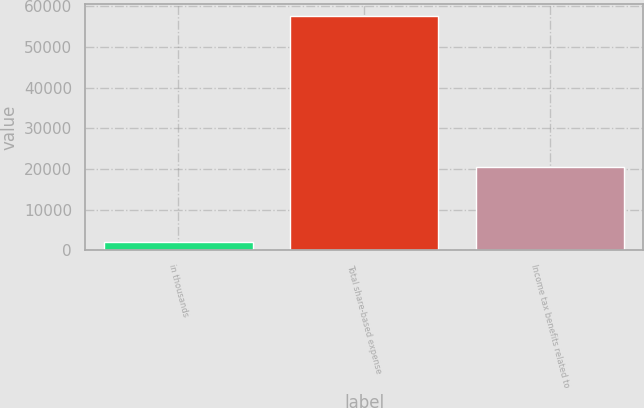Convert chart. <chart><loc_0><loc_0><loc_500><loc_500><bar_chart><fcel>in thousands<fcel>Total share-based expense<fcel>Income tax benefits related to<nl><fcel>2015<fcel>57716<fcel>20516<nl></chart> 